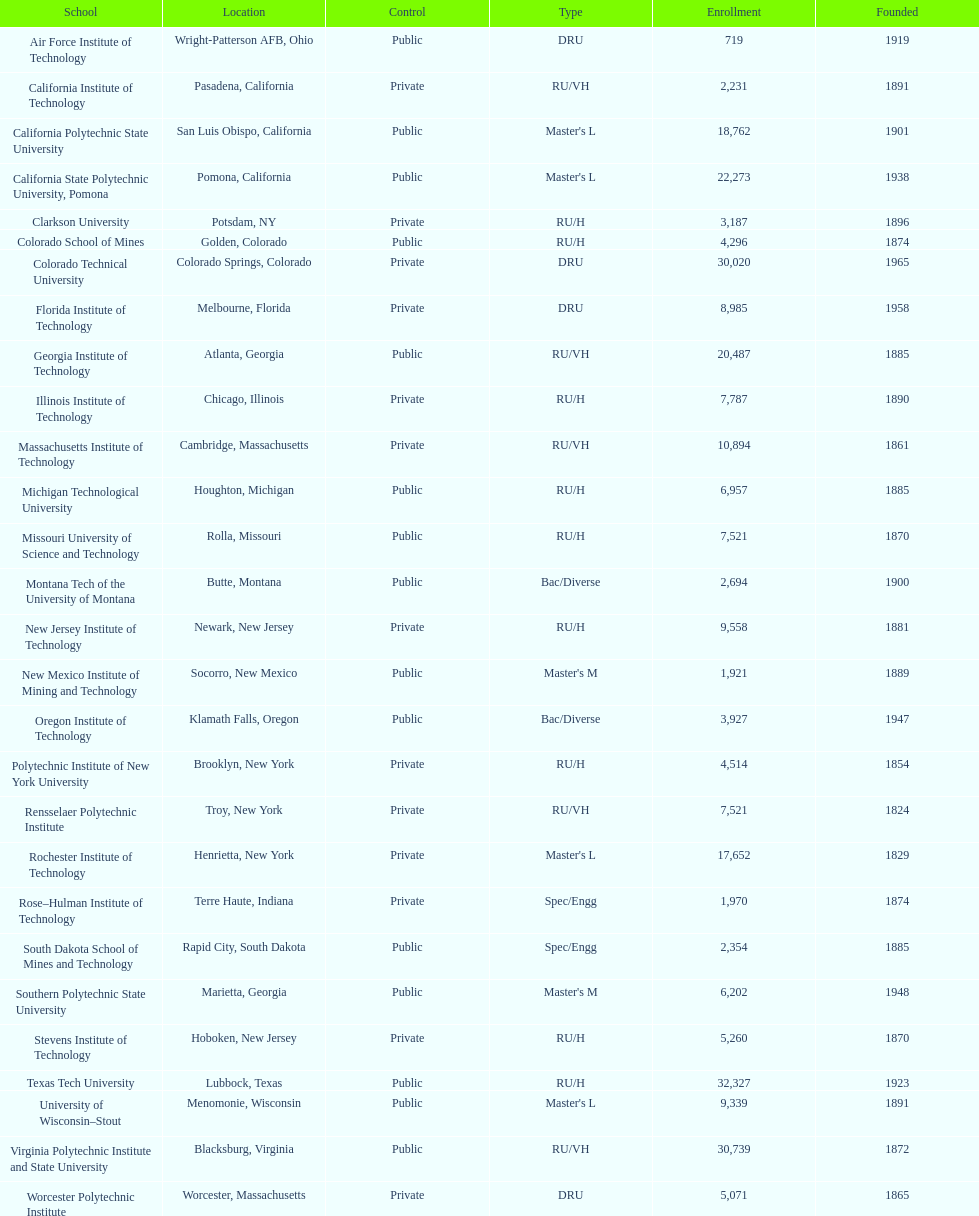Which us technological institute has the highest enrollment figures? Texas Tech University. Could you parse the entire table? {'header': ['School', 'Location', 'Control', 'Type', 'Enrollment', 'Founded'], 'rows': [['Air Force Institute of Technology', 'Wright-Patterson AFB, Ohio', 'Public', 'DRU', '719', '1919'], ['California Institute of Technology', 'Pasadena, California', 'Private', 'RU/VH', '2,231', '1891'], ['California Polytechnic State University', 'San Luis Obispo, California', 'Public', "Master's L", '18,762', '1901'], ['California State Polytechnic University, Pomona', 'Pomona, California', 'Public', "Master's L", '22,273', '1938'], ['Clarkson University', 'Potsdam, NY', 'Private', 'RU/H', '3,187', '1896'], ['Colorado School of Mines', 'Golden, Colorado', 'Public', 'RU/H', '4,296', '1874'], ['Colorado Technical University', 'Colorado Springs, Colorado', 'Private', 'DRU', '30,020', '1965'], ['Florida Institute of Technology', 'Melbourne, Florida', 'Private', 'DRU', '8,985', '1958'], ['Georgia Institute of Technology', 'Atlanta, Georgia', 'Public', 'RU/VH', '20,487', '1885'], ['Illinois Institute of Technology', 'Chicago, Illinois', 'Private', 'RU/H', '7,787', '1890'], ['Massachusetts Institute of Technology', 'Cambridge, Massachusetts', 'Private', 'RU/VH', '10,894', '1861'], ['Michigan Technological University', 'Houghton, Michigan', 'Public', 'RU/H', '6,957', '1885'], ['Missouri University of Science and Technology', 'Rolla, Missouri', 'Public', 'RU/H', '7,521', '1870'], ['Montana Tech of the University of Montana', 'Butte, Montana', 'Public', 'Bac/Diverse', '2,694', '1900'], ['New Jersey Institute of Technology', 'Newark, New Jersey', 'Private', 'RU/H', '9,558', '1881'], ['New Mexico Institute of Mining and Technology', 'Socorro, New Mexico', 'Public', "Master's M", '1,921', '1889'], ['Oregon Institute of Technology', 'Klamath Falls, Oregon', 'Public', 'Bac/Diverse', '3,927', '1947'], ['Polytechnic Institute of New York University', 'Brooklyn, New York', 'Private', 'RU/H', '4,514', '1854'], ['Rensselaer Polytechnic Institute', 'Troy, New York', 'Private', 'RU/VH', '7,521', '1824'], ['Rochester Institute of Technology', 'Henrietta, New York', 'Private', "Master's L", '17,652', '1829'], ['Rose–Hulman Institute of Technology', 'Terre Haute, Indiana', 'Private', 'Spec/Engg', '1,970', '1874'], ['South Dakota School of Mines and Technology', 'Rapid City, South Dakota', 'Public', 'Spec/Engg', '2,354', '1885'], ['Southern Polytechnic State University', 'Marietta, Georgia', 'Public', "Master's M", '6,202', '1948'], ['Stevens Institute of Technology', 'Hoboken, New Jersey', 'Private', 'RU/H', '5,260', '1870'], ['Texas Tech University', 'Lubbock, Texas', 'Public', 'RU/H', '32,327', '1923'], ['University of Wisconsin–Stout', 'Menomonie, Wisconsin', 'Public', "Master's L", '9,339', '1891'], ['Virginia Polytechnic Institute and State University', 'Blacksburg, Virginia', 'Public', 'RU/VH', '30,739', '1872'], ['Worcester Polytechnic Institute', 'Worcester, Massachusetts', 'Private', 'DRU', '5,071', '1865']]} 